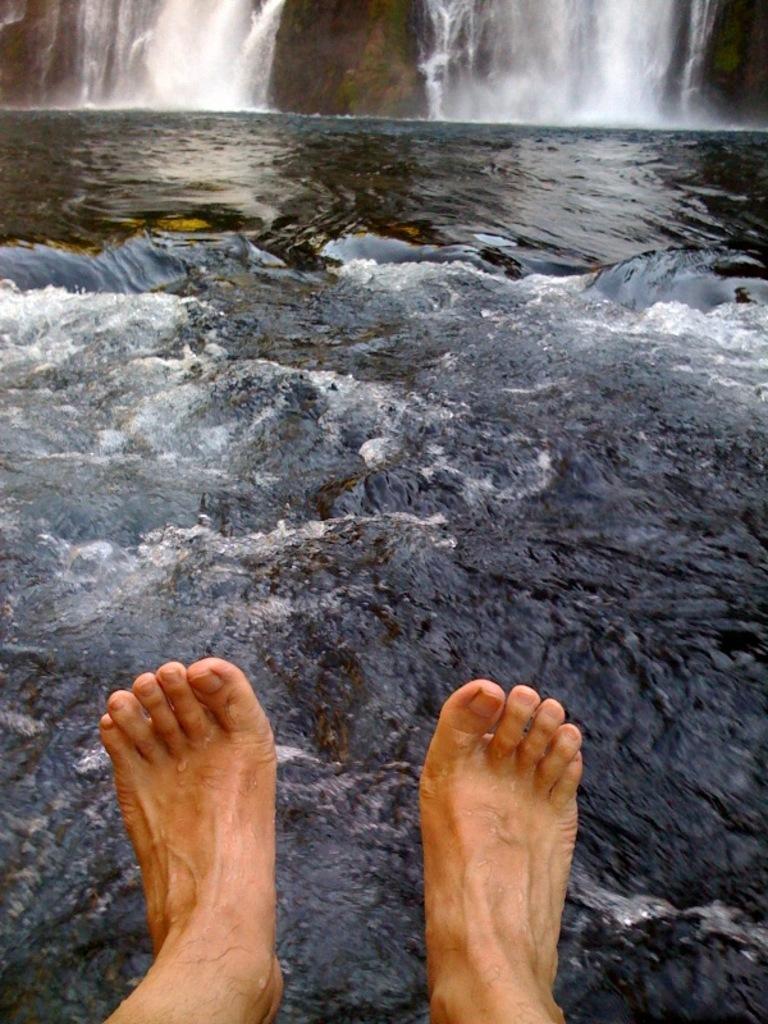In one or two sentences, can you explain what this image depicts? In the foreground of this image, there are feet of a person. Behind it, there is water. At the top, there is the waterfall. 